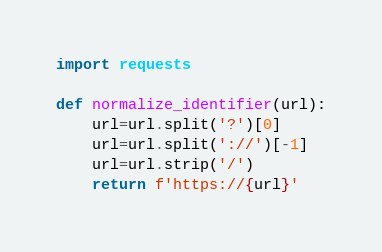<code> <loc_0><loc_0><loc_500><loc_500><_Python_>import requests 

def normalize_identifier(url):
    url=url.split('?')[0]
    url=url.split('://')[-1]
    url=url.strip('/')
    return f'https://{url}'

</code> 